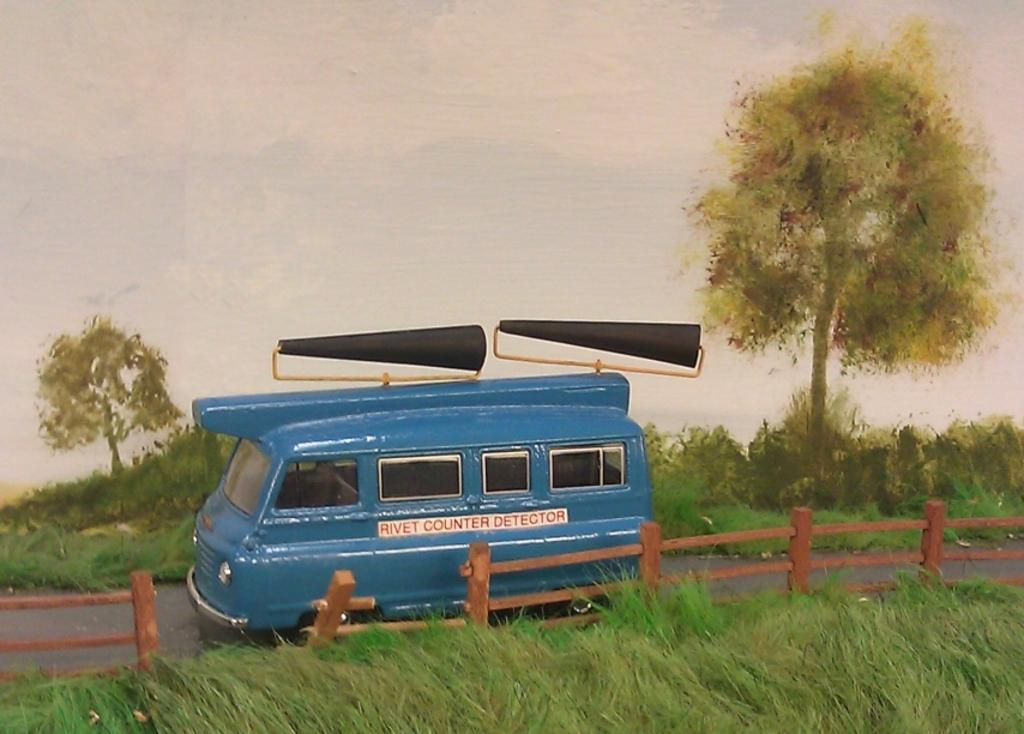What type of vegetation can be seen in the image? There are trees and plants in the image. What type of barrier is present in the image? There is a fence in the image. What type of ground cover is visible in the image? There is grass in the image. What can be seen in the background of the image? The sky is visible in the background of the image. What is the purpose of the text on the vehicle? The text on the vehicle is likely for advertising or identification purposes. How many clouds can be seen in the image? There are no clouds visible in the image; only the sky is visible in the background of the image. What type of bun is being used to hold the vehicle in place? There is no bun present in the image; it is a vehicle on the ground, not a baked good. 